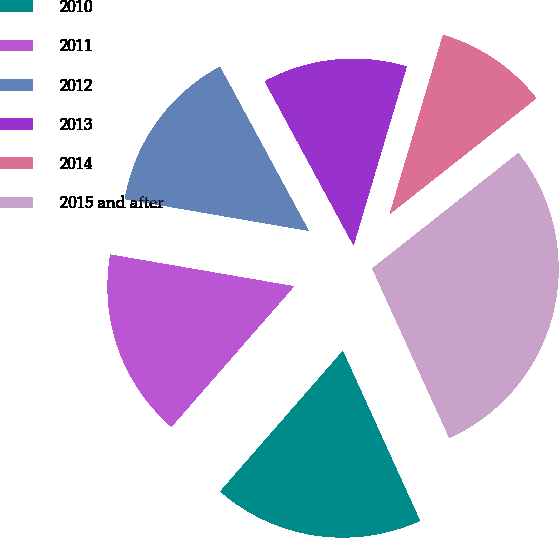Convert chart. <chart><loc_0><loc_0><loc_500><loc_500><pie_chart><fcel>2010<fcel>2011<fcel>2012<fcel>2013<fcel>2014<fcel>2015 and after<nl><fcel>18.21%<fcel>16.3%<fcel>14.39%<fcel>12.49%<fcel>9.76%<fcel>28.85%<nl></chart> 